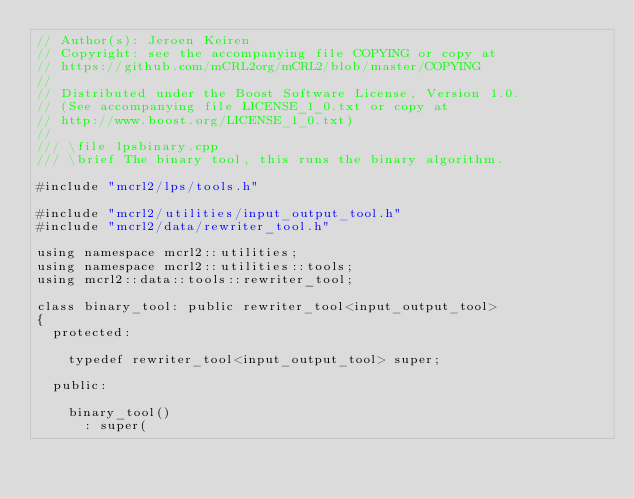<code> <loc_0><loc_0><loc_500><loc_500><_C++_>// Author(s): Jeroen Keiren
// Copyright: see the accompanying file COPYING or copy at
// https://github.com/mCRL2org/mCRL2/blob/master/COPYING
//
// Distributed under the Boost Software License, Version 1.0.
// (See accompanying file LICENSE_1_0.txt or copy at
// http://www.boost.org/LICENSE_1_0.txt)
//
/// \file lpsbinary.cpp
/// \brief The binary tool, this runs the binary algorithm.

#include "mcrl2/lps/tools.h"

#include "mcrl2/utilities/input_output_tool.h"
#include "mcrl2/data/rewriter_tool.h"

using namespace mcrl2::utilities;
using namespace mcrl2::utilities::tools;
using mcrl2::data::tools::rewriter_tool;

class binary_tool: public rewriter_tool<input_output_tool>
{
  protected:

    typedef rewriter_tool<input_output_tool> super;

  public:

    binary_tool()
      : super(</code> 